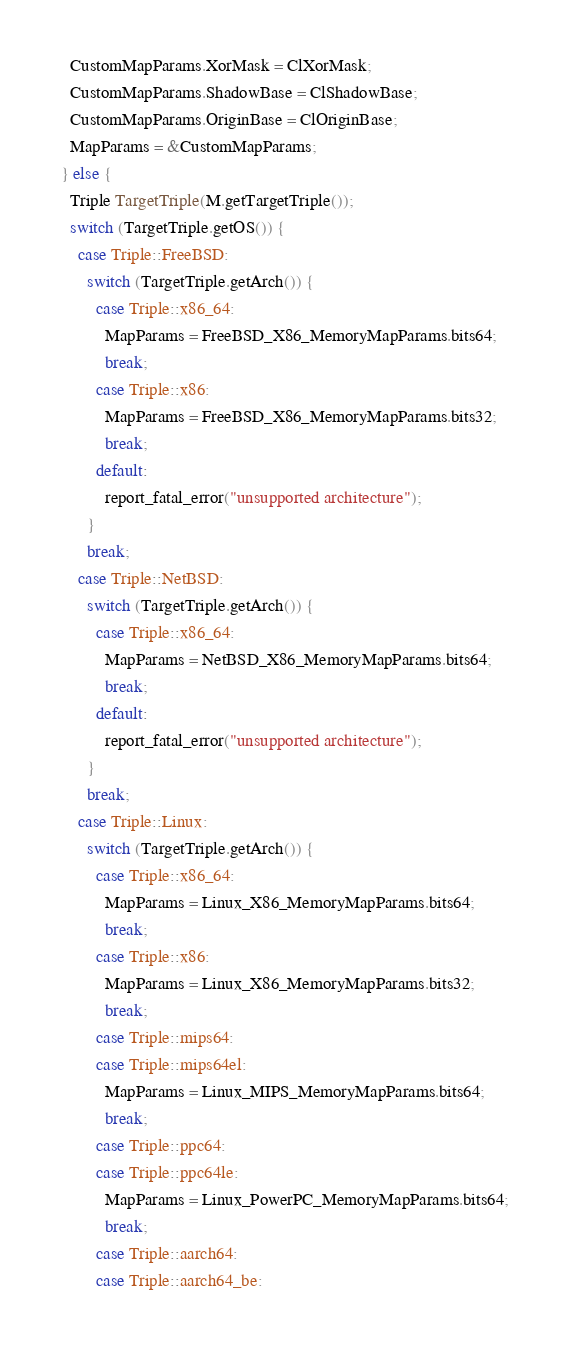<code> <loc_0><loc_0><loc_500><loc_500><_C++_>    CustomMapParams.XorMask = ClXorMask;
    CustomMapParams.ShadowBase = ClShadowBase;
    CustomMapParams.OriginBase = ClOriginBase;
    MapParams = &CustomMapParams;
  } else {
    Triple TargetTriple(M.getTargetTriple());
    switch (TargetTriple.getOS()) {
      case Triple::FreeBSD:
        switch (TargetTriple.getArch()) {
          case Triple::x86_64:
            MapParams = FreeBSD_X86_MemoryMapParams.bits64;
            break;
          case Triple::x86:
            MapParams = FreeBSD_X86_MemoryMapParams.bits32;
            break;
          default:
            report_fatal_error("unsupported architecture");
        }
        break;
      case Triple::NetBSD:
        switch (TargetTriple.getArch()) {
          case Triple::x86_64:
            MapParams = NetBSD_X86_MemoryMapParams.bits64;
            break;
          default:
            report_fatal_error("unsupported architecture");
        }
        break;
      case Triple::Linux:
        switch (TargetTriple.getArch()) {
          case Triple::x86_64:
            MapParams = Linux_X86_MemoryMapParams.bits64;
            break;
          case Triple::x86:
            MapParams = Linux_X86_MemoryMapParams.bits32;
            break;
          case Triple::mips64:
          case Triple::mips64el:
            MapParams = Linux_MIPS_MemoryMapParams.bits64;
            break;
          case Triple::ppc64:
          case Triple::ppc64le:
            MapParams = Linux_PowerPC_MemoryMapParams.bits64;
            break;
          case Triple::aarch64:
          case Triple::aarch64_be:</code> 